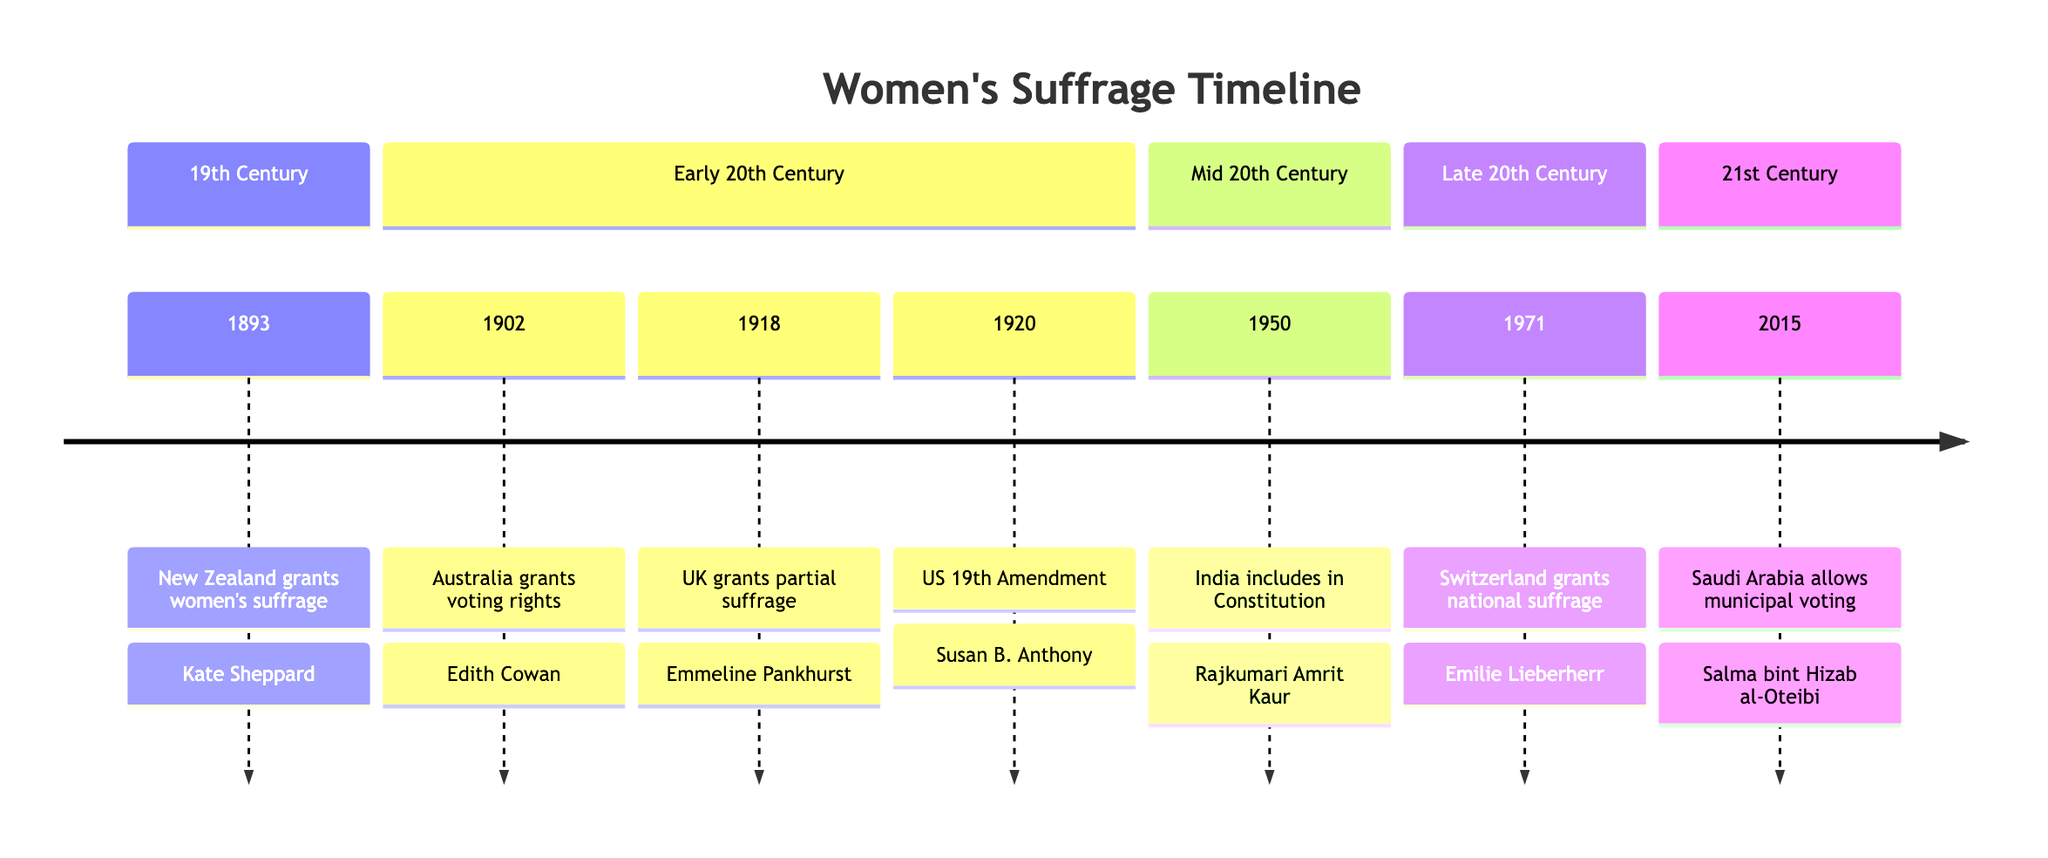What year did New Zealand grant women's suffrage? The diagram lists New Zealand as the first country to grant women's suffrage in the year 1893. Therefore, by looking at the timeline, we can directly find the year associated with New Zealand.
Answer: 1893 Who was the key figure associated with the Australian women's suffrage movement? The timeline indicates that Australia granted women the right to vote and run for parliament in 1902, and it credits Edith Cowan as the key figure for this event. Hence, the key figure for the Australian movement is found by directly referencing the information presented.
Answer: Edith Cowan Which country was the last to grant women's suffrage, according to the timeline? By examining the timeline, we see that Saudi Arabia allowed women to vote and run in municipal elections in 2015, making it the last country listed for granting women's suffrage. This can be determined by comparing the years shown for each country.
Answer: Saudi Arabia What event occurred in Switzerland in 1971? The timeline shows that in 1971, Switzerland granted national women's suffrage, which is specifically mentioned in that section. This allows us to directly refer to the event associated with Switzerland in that year.
Answer: Granted national suffrage How many countries are represented in the timeline? Observing the timeline, we count seven distinct countries, each associated with a separate event regarding women's suffrage. To determine the total number, we can simply add each entry listed in the timeline.
Answer: 7 Which country granted women the right to vote as part of its Constitution? The timeline specifies that India included women's suffrage rights in its Constitution in 1950, allowing us to directly connect the country to the specific event mentioned.
Answer: India What was the key figure in the United States' suffrage movement? According to the timeline, the 19th Amendment in the United States, which granted women the right to vote in 1920, is attributed to Susan B. Anthony as the key figure in this movement. Thus, we can find the key figure by referencing the US entry.
Answer: Susan B. Anthony Which country's suffrage movement was represented by Emmeline Pankhurst? The timeline outlines that Emmeline Pankhurst is associated with the women's suffrage movement in the United Kingdom, where women over 30 were granted the vote in 1918. This relationship is clearly spelled out in the diagram, allowing us to answer correctly.
Answer: United Kingdom 